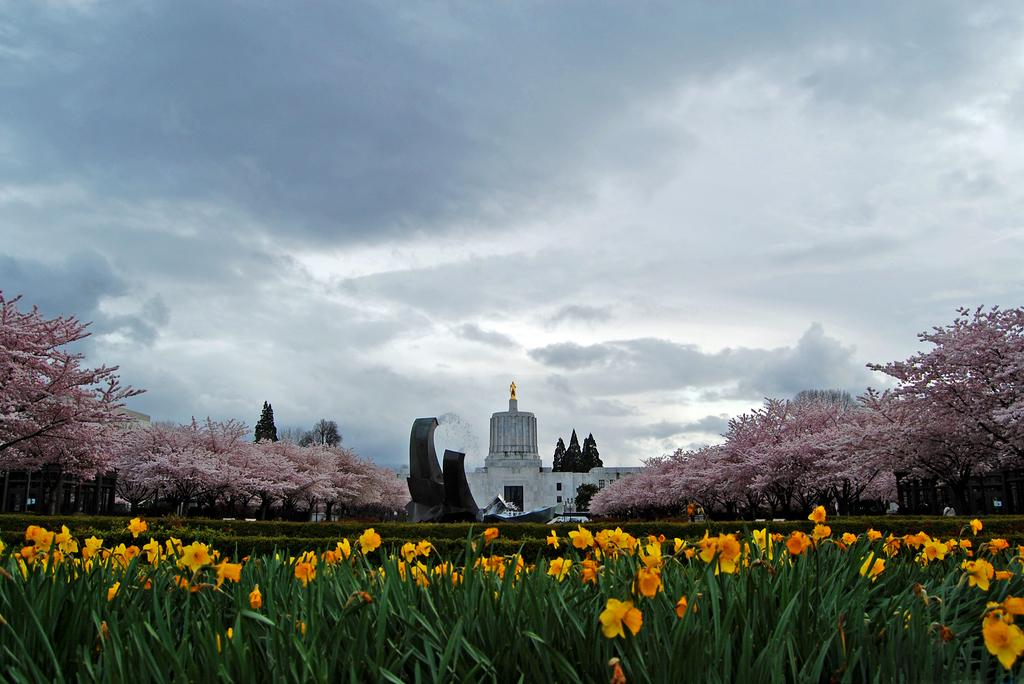What is the main structure in the image? There is a building in the image. What can be seen beside the building? There are many trees beside the building. What type of vegetation is present at the bottom of the image? There are flowers along with plants at the bottom of the image. What is visible in the sky at the top of the image? There are clouds in the sky at the top of the image. Can you tell me how many worms are crawling on the sidewalk in the image? There is no sidewalk or worms present in the image. 